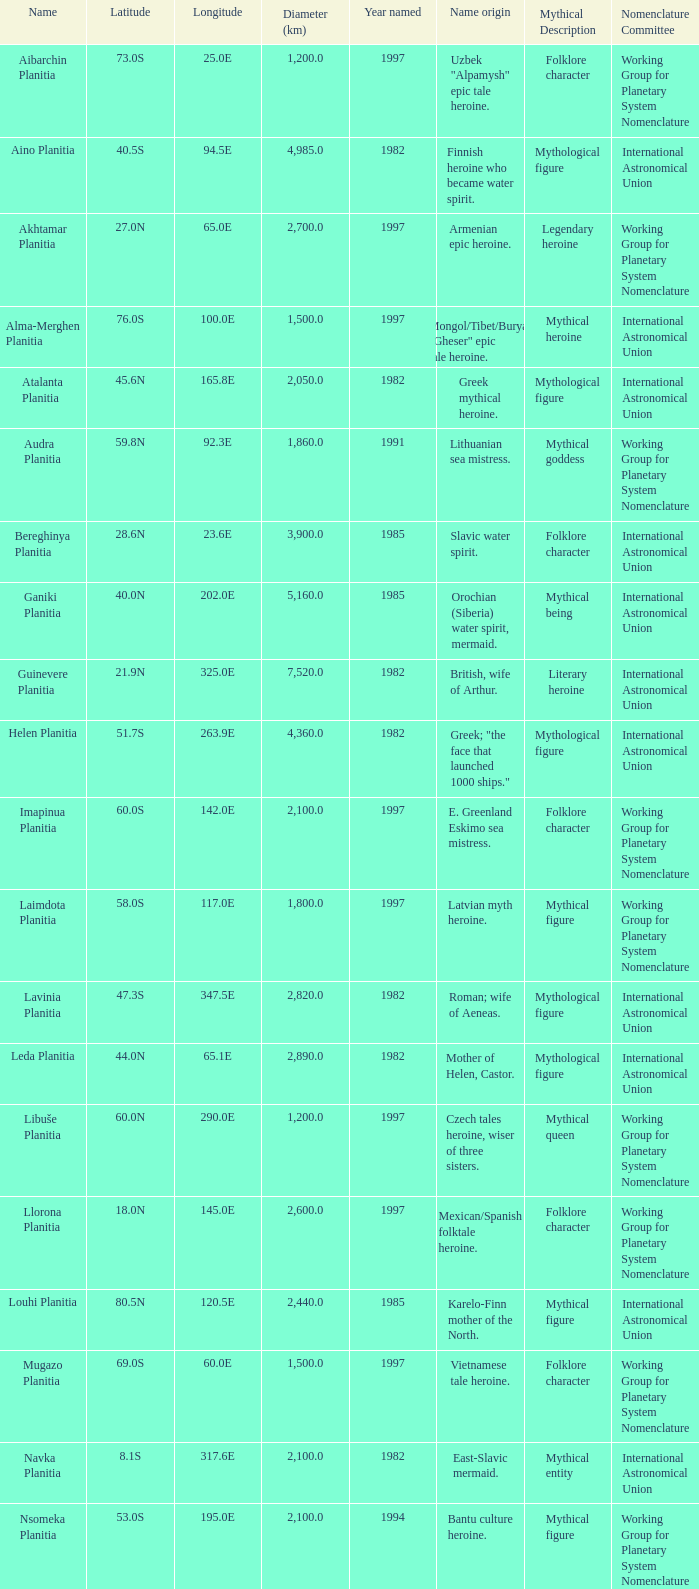What is the diameter (km) of feature of latitude 40.5s 4985.0. 